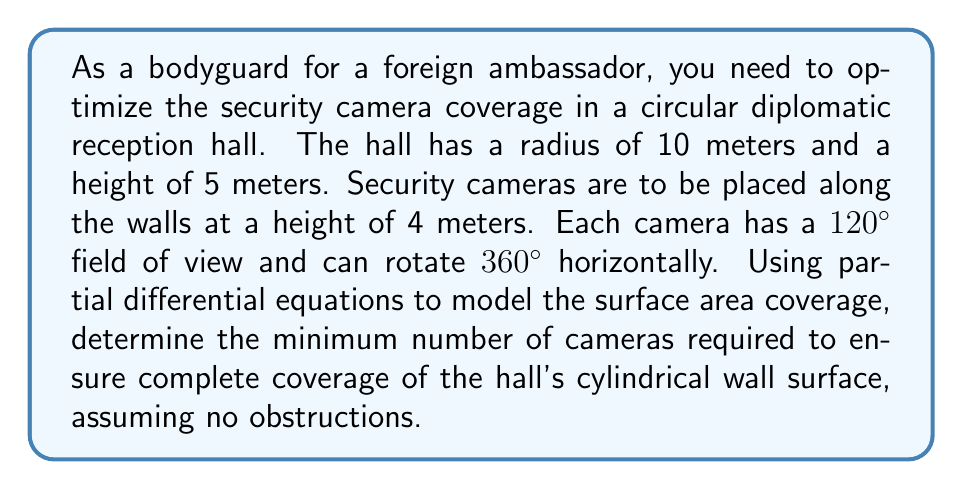Can you answer this question? To solve this problem, we need to use partial differential equations to model the surface area coverage of the security cameras. Let's approach this step-by-step:

1) First, we need to calculate the total surface area of the cylindrical wall:
   $$ A = 2\pi rh $$
   where $r$ is the radius and $h$ is the height of the cylindrical portion.
   $$ A = 2\pi \cdot 10 \cdot 5 = 100\pi \approx 314.16 \text{ m}^2 $$

2) Now, let's consider the coverage of a single camera. The camera's field of view forms a spherical cap on the cylindrical surface. We can model this using spherical coordinates and the surface area element:
   $$ dA = r^2 \sin\theta \, d\theta \, d\phi $$

3) The coverage of a single camera can be expressed as an integral:
   $$ A_{\text{camera}} = \int_0^{2\pi} \int_0^{\pi/3} r^2 \sin\theta \, d\theta \, d\phi $$
   where $\pi/3$ represents the 60° angle from the camera's central axis (half of the 120° field of view).

4) Solving this integral:
   $$ A_{\text{camera}} = 2\pi r^2 \left[-\cos\theta\right]_0^{\pi/3} = 2\pi r^2 (1 - \cos(\pi/3)) $$
   $$ A_{\text{camera}} = 2\pi \cdot 10^2 \cdot (1 - \frac{1}{2}) = 100\pi \approx 314.16 \text{ m}^2 $$

5) However, this is the surface area of a sphere. We need to find the intersection of this spherical cap with the cylindrical wall. This forms a complex shape that can be approximated using numerical methods or simplified geometric models.

6) A reasonable approximation is to consider the camera's coverage as a rectangle on the cylindrical surface:
   $$ A_{\text{camera}} \approx 2\pi r \cdot \frac{1}{3}h = \frac{2\pi rh}{3} $$
   $$ A_{\text{camera}} \approx \frac{2\pi \cdot 10 \cdot 5}{3} \approx 104.72 \text{ m}^2 $$

7) The number of cameras needed is then:
   $$ N = \ceil{\frac{A}{A_{\text{camera}}}} = \ceil{\frac{100\pi}{104.72}} = \ceil{3} = 3 $$

Therefore, a minimum of 3 cameras are required to ensure complete coverage of the hall's cylindrical wall surface.
Answer: 3 cameras 